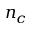Convert formula to latex. <formula><loc_0><loc_0><loc_500><loc_500>n _ { c }</formula> 